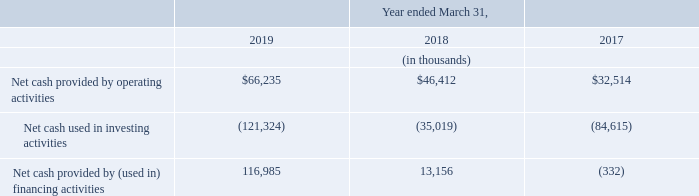Liquidity and Capital Resources
Our principal sources of liquidity are cash and cash equivalents, investments and accounts receivable. The following table shows net cash provided by operating activities, net cash used in investing activities, and net cash provided by (used in) financing activities for the years ended March 31, 2019, 2018 and 2017:
In November 2015, we raised net proceeds of $68.3 million in our initial public offering after deducting underwriting discounts and commissions and offering expenses paid by us. In the years ended March 31, 2019, 2018 and 2017, we incurred operating losses of $1.2 million, $7.0 million and $10.4 million, respectively. While we expect to generate an operating loss in the year ending March 31, 2020, we expect to continue to generate positive cash flows from operating activities.
In the year ending March 31, 2020, we plan to continue to invest in the development and expansion of our Mime | OS™ platform to improve on our existing solutions in order to provide more capabilities to our customers. Investments in capital expenditures in the year ended March 31, 2019 were $28.8 million of which $25.8 million related to the expansion of our grid architecture.
We expect fiscal year 2020 capital expenditures to increase significantly as we expect to incur one-time costs related to the build out and expansion of facilities in the U.K. and other locations and additional data center expansion primarily in the U.S.
As of March 31, 2019 and 2018, we had cash, cash equivalents and investments of $173.5 million and $137.2 million, respectively. Based on our current operating plan, we believe that our current cash and cash equivalents, investments and operating cash flows will be sufficient to fund our operations for at least the next twelve months. Our future capital requirements may vary materially from those planned and will depend on certain factors, such as our growth and our operating results.
If we require additional capital resources to grow our business or to acquire complementary technologies and businesses in the future, we may seek to sell additional equity or raise funds through debt financing or other sources. We may also seek to invest in or acquire complement ary businesses, applications or technologies, any of which could also require us to seek additional equity or debt financing.
We cannot provide assurance that additional financing will be available at all or on terms favorable to us. We had no material commitments for capital expenditures as of March 31, 2019 or 2018.
What are the principal sources of liquidity? Cash and cash equivalents, investments and accounts receivable. What was the net proceeds raised in 2015? $68.3 million. What was the Net cash provided by operating activities in 2019, 2018 and 2017 respectively?
Answer scale should be: thousand. $66,235, $46,412, $32,514. What was the change in the Net cash provided by operating activities from 2018 to 2019?
Answer scale should be: thousand. 66,235 - 46,412
Answer: 19823. What was the average Net cash used in investing activities between 2017 to 2019?
Answer scale should be: thousand. -(121,324 + 35,019 + 84,615) / 3
Answer: -80319.33. In which year was Net cash provided by (used in) financing activities less than 25,000 thousands? Locate and analyze net cash provided by (used in) financing activities in row 6
answer: 2018, 2017. 